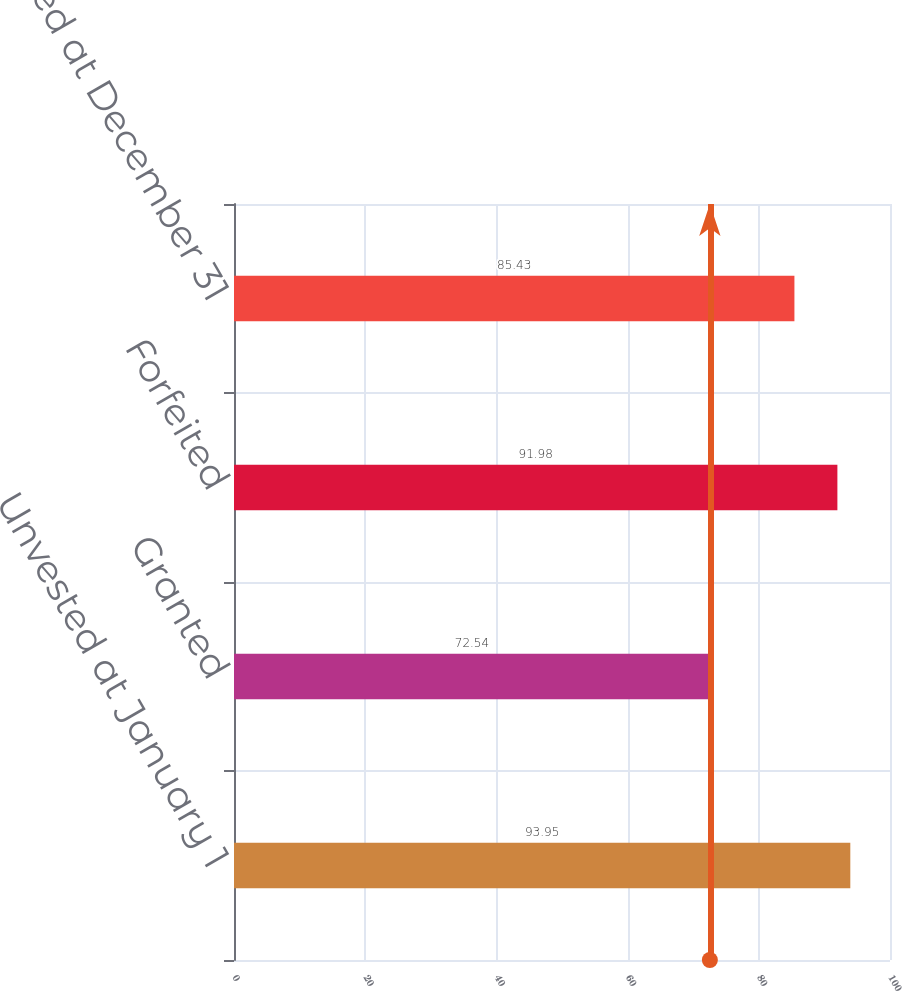Convert chart. <chart><loc_0><loc_0><loc_500><loc_500><bar_chart><fcel>Unvested at January 1<fcel>Granted<fcel>Forfeited<fcel>Unvested at December 31<nl><fcel>93.95<fcel>72.54<fcel>91.98<fcel>85.43<nl></chart> 